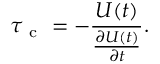Convert formula to latex. <formula><loc_0><loc_0><loc_500><loc_500>\tau _ { c } = - \frac { U ( t ) } { \frac { \partial U ( t ) } { \partial t } } .</formula> 